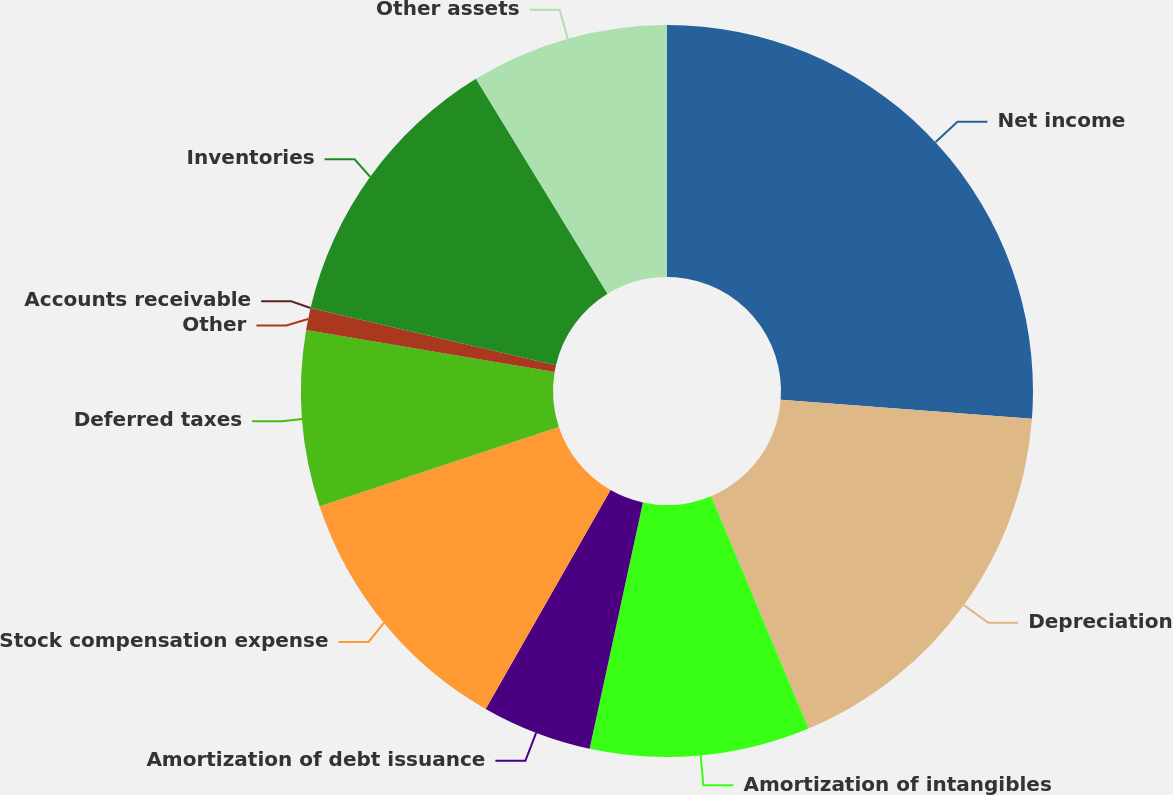Convert chart. <chart><loc_0><loc_0><loc_500><loc_500><pie_chart><fcel>Net income<fcel>Depreciation<fcel>Amortization of intangibles<fcel>Amortization of debt issuance<fcel>Stock compensation expense<fcel>Deferred taxes<fcel>Other<fcel>Accounts receivable<fcel>Inventories<fcel>Other assets<nl><fcel>26.21%<fcel>17.47%<fcel>9.71%<fcel>4.86%<fcel>11.65%<fcel>7.77%<fcel>0.97%<fcel>0.0%<fcel>12.62%<fcel>8.74%<nl></chart> 